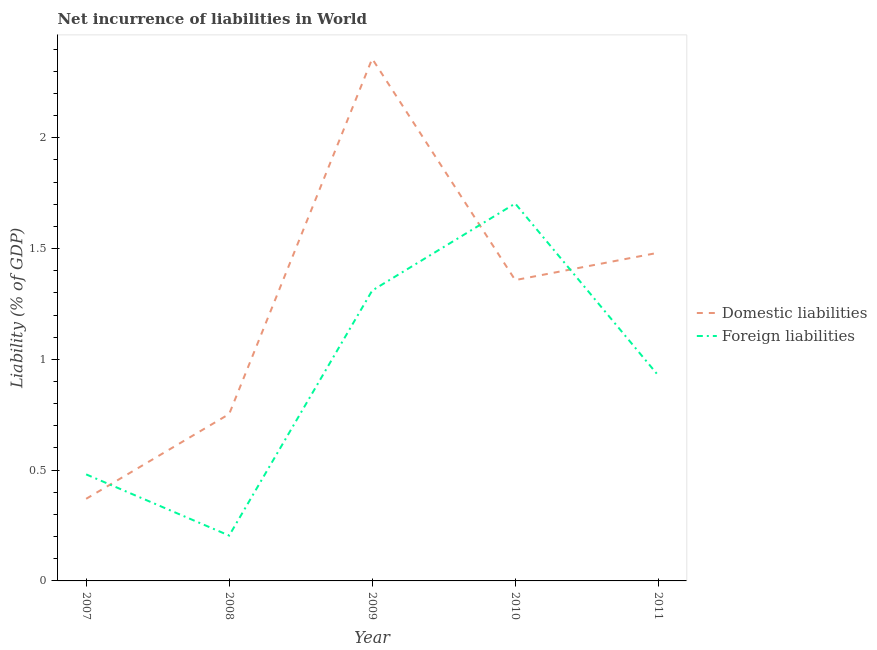Does the line corresponding to incurrence of foreign liabilities intersect with the line corresponding to incurrence of domestic liabilities?
Your answer should be very brief. Yes. What is the incurrence of foreign liabilities in 2010?
Offer a terse response. 1.7. Across all years, what is the maximum incurrence of domestic liabilities?
Make the answer very short. 2.36. Across all years, what is the minimum incurrence of domestic liabilities?
Ensure brevity in your answer.  0.37. In which year was the incurrence of foreign liabilities maximum?
Make the answer very short. 2010. What is the total incurrence of foreign liabilities in the graph?
Offer a very short reply. 4.63. What is the difference between the incurrence of foreign liabilities in 2008 and that in 2009?
Your response must be concise. -1.11. What is the difference between the incurrence of domestic liabilities in 2007 and the incurrence of foreign liabilities in 2010?
Your response must be concise. -1.33. What is the average incurrence of domestic liabilities per year?
Provide a succinct answer. 1.26. In the year 2008, what is the difference between the incurrence of domestic liabilities and incurrence of foreign liabilities?
Keep it short and to the point. 0.55. In how many years, is the incurrence of foreign liabilities greater than 0.6 %?
Your answer should be compact. 3. What is the ratio of the incurrence of domestic liabilities in 2010 to that in 2011?
Your response must be concise. 0.92. Is the difference between the incurrence of foreign liabilities in 2009 and 2011 greater than the difference between the incurrence of domestic liabilities in 2009 and 2011?
Offer a very short reply. No. What is the difference between the highest and the second highest incurrence of foreign liabilities?
Provide a short and direct response. 0.39. What is the difference between the highest and the lowest incurrence of foreign liabilities?
Make the answer very short. 1.5. Is the sum of the incurrence of domestic liabilities in 2007 and 2008 greater than the maximum incurrence of foreign liabilities across all years?
Offer a terse response. No. How many lines are there?
Ensure brevity in your answer.  2. How many years are there in the graph?
Give a very brief answer. 5. Are the values on the major ticks of Y-axis written in scientific E-notation?
Your answer should be very brief. No. Does the graph contain grids?
Your answer should be compact. No. How are the legend labels stacked?
Give a very brief answer. Vertical. What is the title of the graph?
Your answer should be compact. Net incurrence of liabilities in World. What is the label or title of the X-axis?
Your answer should be very brief. Year. What is the label or title of the Y-axis?
Offer a very short reply. Liability (% of GDP). What is the Liability (% of GDP) in Domestic liabilities in 2007?
Ensure brevity in your answer.  0.37. What is the Liability (% of GDP) in Foreign liabilities in 2007?
Provide a succinct answer. 0.48. What is the Liability (% of GDP) of Domestic liabilities in 2008?
Provide a succinct answer. 0.75. What is the Liability (% of GDP) of Foreign liabilities in 2008?
Your answer should be compact. 0.2. What is the Liability (% of GDP) in Domestic liabilities in 2009?
Ensure brevity in your answer.  2.36. What is the Liability (% of GDP) in Foreign liabilities in 2009?
Ensure brevity in your answer.  1.31. What is the Liability (% of GDP) in Domestic liabilities in 2010?
Make the answer very short. 1.36. What is the Liability (% of GDP) in Foreign liabilities in 2010?
Your answer should be very brief. 1.7. What is the Liability (% of GDP) in Domestic liabilities in 2011?
Keep it short and to the point. 1.48. What is the Liability (% of GDP) of Foreign liabilities in 2011?
Provide a short and direct response. 0.93. Across all years, what is the maximum Liability (% of GDP) of Domestic liabilities?
Your answer should be compact. 2.36. Across all years, what is the maximum Liability (% of GDP) of Foreign liabilities?
Provide a short and direct response. 1.7. Across all years, what is the minimum Liability (% of GDP) of Domestic liabilities?
Make the answer very short. 0.37. Across all years, what is the minimum Liability (% of GDP) of Foreign liabilities?
Your response must be concise. 0.2. What is the total Liability (% of GDP) in Domestic liabilities in the graph?
Offer a very short reply. 6.32. What is the total Liability (% of GDP) of Foreign liabilities in the graph?
Ensure brevity in your answer.  4.63. What is the difference between the Liability (% of GDP) in Domestic liabilities in 2007 and that in 2008?
Your answer should be very brief. -0.38. What is the difference between the Liability (% of GDP) in Foreign liabilities in 2007 and that in 2008?
Your answer should be very brief. 0.28. What is the difference between the Liability (% of GDP) in Domestic liabilities in 2007 and that in 2009?
Make the answer very short. -1.99. What is the difference between the Liability (% of GDP) of Foreign liabilities in 2007 and that in 2009?
Offer a terse response. -0.83. What is the difference between the Liability (% of GDP) of Domestic liabilities in 2007 and that in 2010?
Your response must be concise. -0.99. What is the difference between the Liability (% of GDP) of Foreign liabilities in 2007 and that in 2010?
Provide a succinct answer. -1.22. What is the difference between the Liability (% of GDP) of Domestic liabilities in 2007 and that in 2011?
Ensure brevity in your answer.  -1.11. What is the difference between the Liability (% of GDP) of Foreign liabilities in 2007 and that in 2011?
Your response must be concise. -0.45. What is the difference between the Liability (% of GDP) in Domestic liabilities in 2008 and that in 2009?
Offer a very short reply. -1.6. What is the difference between the Liability (% of GDP) in Foreign liabilities in 2008 and that in 2009?
Make the answer very short. -1.11. What is the difference between the Liability (% of GDP) of Domestic liabilities in 2008 and that in 2010?
Provide a short and direct response. -0.6. What is the difference between the Liability (% of GDP) of Foreign liabilities in 2008 and that in 2010?
Your response must be concise. -1.5. What is the difference between the Liability (% of GDP) in Domestic liabilities in 2008 and that in 2011?
Your response must be concise. -0.73. What is the difference between the Liability (% of GDP) of Foreign liabilities in 2008 and that in 2011?
Your response must be concise. -0.72. What is the difference between the Liability (% of GDP) of Domestic liabilities in 2009 and that in 2010?
Provide a short and direct response. 1. What is the difference between the Liability (% of GDP) in Foreign liabilities in 2009 and that in 2010?
Keep it short and to the point. -0.39. What is the difference between the Liability (% of GDP) in Domestic liabilities in 2009 and that in 2011?
Offer a terse response. 0.88. What is the difference between the Liability (% of GDP) in Foreign liabilities in 2009 and that in 2011?
Your response must be concise. 0.38. What is the difference between the Liability (% of GDP) in Domestic liabilities in 2010 and that in 2011?
Provide a short and direct response. -0.12. What is the difference between the Liability (% of GDP) of Foreign liabilities in 2010 and that in 2011?
Offer a very short reply. 0.78. What is the difference between the Liability (% of GDP) in Domestic liabilities in 2007 and the Liability (% of GDP) in Foreign liabilities in 2008?
Provide a short and direct response. 0.17. What is the difference between the Liability (% of GDP) of Domestic liabilities in 2007 and the Liability (% of GDP) of Foreign liabilities in 2009?
Provide a succinct answer. -0.94. What is the difference between the Liability (% of GDP) of Domestic liabilities in 2007 and the Liability (% of GDP) of Foreign liabilities in 2010?
Offer a terse response. -1.33. What is the difference between the Liability (% of GDP) of Domestic liabilities in 2007 and the Liability (% of GDP) of Foreign liabilities in 2011?
Provide a succinct answer. -0.56. What is the difference between the Liability (% of GDP) in Domestic liabilities in 2008 and the Liability (% of GDP) in Foreign liabilities in 2009?
Offer a very short reply. -0.56. What is the difference between the Liability (% of GDP) in Domestic liabilities in 2008 and the Liability (% of GDP) in Foreign liabilities in 2010?
Make the answer very short. -0.95. What is the difference between the Liability (% of GDP) in Domestic liabilities in 2008 and the Liability (% of GDP) in Foreign liabilities in 2011?
Offer a terse response. -0.17. What is the difference between the Liability (% of GDP) in Domestic liabilities in 2009 and the Liability (% of GDP) in Foreign liabilities in 2010?
Offer a terse response. 0.65. What is the difference between the Liability (% of GDP) in Domestic liabilities in 2009 and the Liability (% of GDP) in Foreign liabilities in 2011?
Your answer should be very brief. 1.43. What is the difference between the Liability (% of GDP) of Domestic liabilities in 2010 and the Liability (% of GDP) of Foreign liabilities in 2011?
Your response must be concise. 0.43. What is the average Liability (% of GDP) in Domestic liabilities per year?
Offer a very short reply. 1.26. What is the average Liability (% of GDP) in Foreign liabilities per year?
Offer a terse response. 0.93. In the year 2007, what is the difference between the Liability (% of GDP) of Domestic liabilities and Liability (% of GDP) of Foreign liabilities?
Provide a short and direct response. -0.11. In the year 2008, what is the difference between the Liability (% of GDP) of Domestic liabilities and Liability (% of GDP) of Foreign liabilities?
Your answer should be very brief. 0.55. In the year 2009, what is the difference between the Liability (% of GDP) in Domestic liabilities and Liability (% of GDP) in Foreign liabilities?
Ensure brevity in your answer.  1.05. In the year 2010, what is the difference between the Liability (% of GDP) of Domestic liabilities and Liability (% of GDP) of Foreign liabilities?
Your answer should be compact. -0.35. In the year 2011, what is the difference between the Liability (% of GDP) of Domestic liabilities and Liability (% of GDP) of Foreign liabilities?
Ensure brevity in your answer.  0.55. What is the ratio of the Liability (% of GDP) of Domestic liabilities in 2007 to that in 2008?
Give a very brief answer. 0.49. What is the ratio of the Liability (% of GDP) in Foreign liabilities in 2007 to that in 2008?
Give a very brief answer. 2.35. What is the ratio of the Liability (% of GDP) in Domestic liabilities in 2007 to that in 2009?
Offer a terse response. 0.16. What is the ratio of the Liability (% of GDP) of Foreign liabilities in 2007 to that in 2009?
Offer a terse response. 0.37. What is the ratio of the Liability (% of GDP) in Domestic liabilities in 2007 to that in 2010?
Make the answer very short. 0.27. What is the ratio of the Liability (% of GDP) of Foreign liabilities in 2007 to that in 2010?
Keep it short and to the point. 0.28. What is the ratio of the Liability (% of GDP) of Domestic liabilities in 2007 to that in 2011?
Provide a short and direct response. 0.25. What is the ratio of the Liability (% of GDP) in Foreign liabilities in 2007 to that in 2011?
Your answer should be compact. 0.52. What is the ratio of the Liability (% of GDP) in Domestic liabilities in 2008 to that in 2009?
Provide a short and direct response. 0.32. What is the ratio of the Liability (% of GDP) of Foreign liabilities in 2008 to that in 2009?
Your answer should be very brief. 0.16. What is the ratio of the Liability (% of GDP) in Domestic liabilities in 2008 to that in 2010?
Ensure brevity in your answer.  0.55. What is the ratio of the Liability (% of GDP) in Foreign liabilities in 2008 to that in 2010?
Your answer should be compact. 0.12. What is the ratio of the Liability (% of GDP) in Domestic liabilities in 2008 to that in 2011?
Offer a very short reply. 0.51. What is the ratio of the Liability (% of GDP) in Foreign liabilities in 2008 to that in 2011?
Make the answer very short. 0.22. What is the ratio of the Liability (% of GDP) in Domestic liabilities in 2009 to that in 2010?
Your answer should be very brief. 1.74. What is the ratio of the Liability (% of GDP) in Foreign liabilities in 2009 to that in 2010?
Your answer should be compact. 0.77. What is the ratio of the Liability (% of GDP) of Domestic liabilities in 2009 to that in 2011?
Provide a succinct answer. 1.59. What is the ratio of the Liability (% of GDP) in Foreign liabilities in 2009 to that in 2011?
Give a very brief answer. 1.41. What is the ratio of the Liability (% of GDP) of Foreign liabilities in 2010 to that in 2011?
Provide a short and direct response. 1.84. What is the difference between the highest and the second highest Liability (% of GDP) of Domestic liabilities?
Keep it short and to the point. 0.88. What is the difference between the highest and the second highest Liability (% of GDP) in Foreign liabilities?
Give a very brief answer. 0.39. What is the difference between the highest and the lowest Liability (% of GDP) of Domestic liabilities?
Offer a very short reply. 1.99. What is the difference between the highest and the lowest Liability (% of GDP) of Foreign liabilities?
Provide a short and direct response. 1.5. 